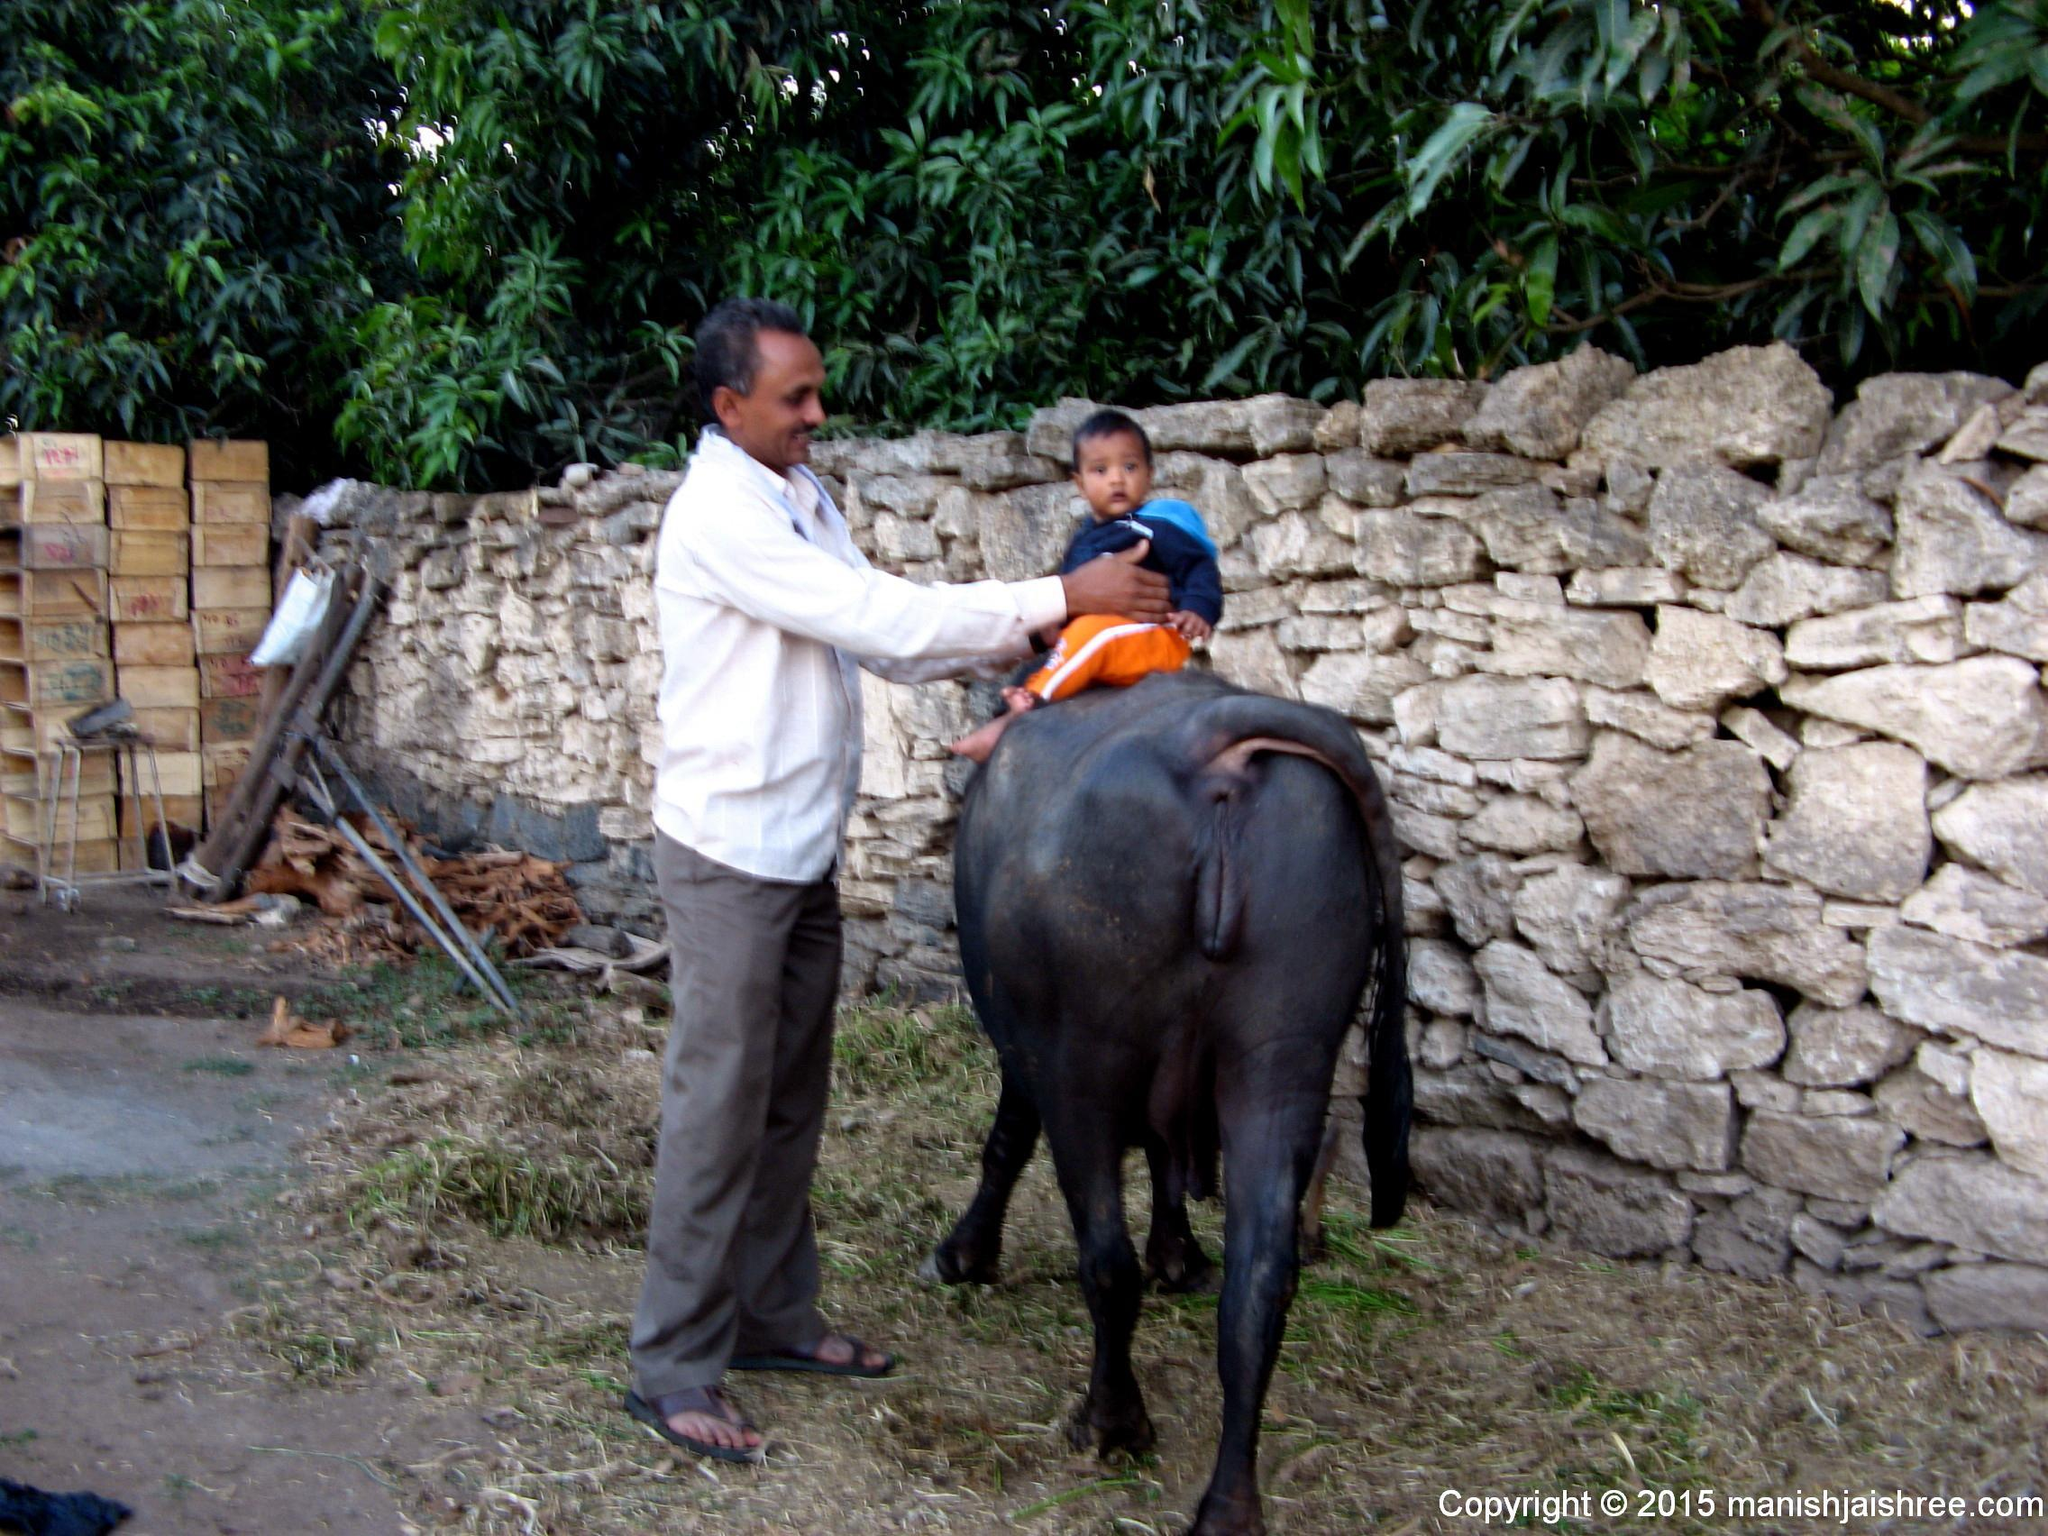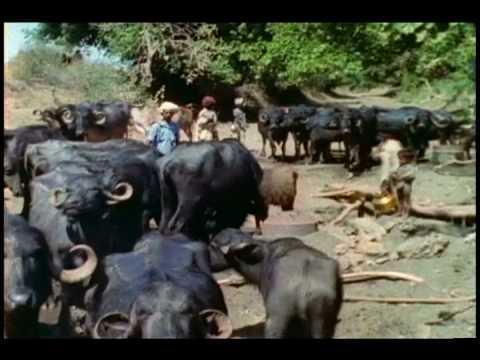The first image is the image on the left, the second image is the image on the right. Given the left and right images, does the statement "Some animals are laying in mud." hold true? Answer yes or no. No. The first image is the image on the left, the second image is the image on the right. For the images displayed, is the sentence "Two or more humans are visible." factually correct? Answer yes or no. Yes. 